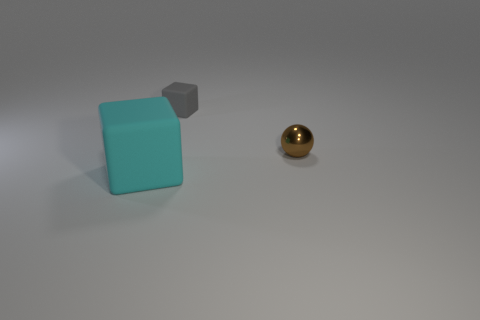Are there any other things that have the same size as the cyan block?
Offer a terse response. No. How many objects are tiny metal spheres or purple metal cylinders?
Your answer should be compact. 1. How many other things are there of the same size as the gray object?
Your response must be concise. 1. There is a large rubber block; is it the same color as the block that is behind the small brown metal object?
Provide a short and direct response. No. How many cylinders are small brown metal objects or gray rubber objects?
Your answer should be compact. 0. Is there anything else that is the same color as the metallic object?
Your response must be concise. No. What material is the small sphere to the right of the matte thing in front of the metal ball made of?
Keep it short and to the point. Metal. Is the tiny sphere made of the same material as the thing to the left of the tiny gray thing?
Offer a terse response. No. How many things are rubber cubes that are in front of the brown ball or purple rubber spheres?
Your answer should be very brief. 1. Are there any tiny cubes that have the same color as the tiny ball?
Your response must be concise. No. 